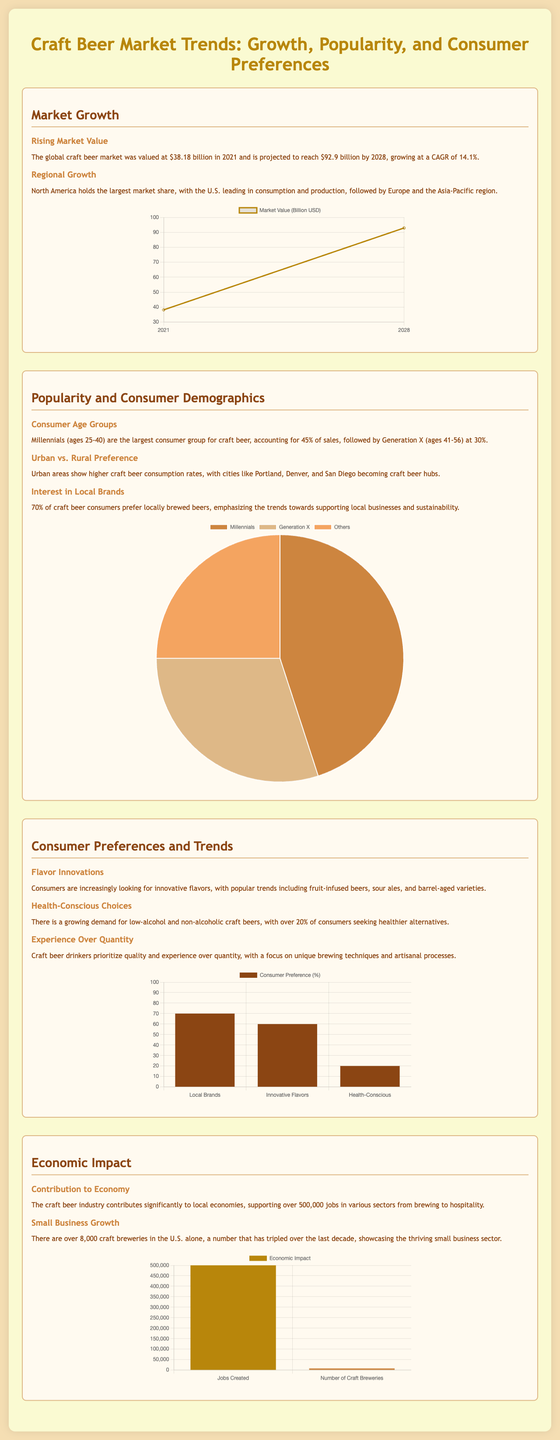What was the global craft beer market value in 2021? The document states that the craft beer market was valued at $38.18 billion in 2021.
Answer: $38.18 billion What is the projected market value by 2028? The document mentions that the market is projected to reach $92.9 billion by 2028.
Answer: $92.9 billion Which age group accounts for the largest consumer group for craft beer? The document states that Millennials (ages 25-40) are the largest consumer group, accounting for 45% of sales.
Answer: Millennials What percentage of craft beer consumers prefer locally brewed beers? According to the document, 70% of craft beer consumers prefer locally brewed beers.
Answer: 70% What is the annual growth rate of the craft beer market? The document indicates that the craft beer market is growing at a CAGR of 14.1%.
Answer: 14.1% How many jobs does the craft beer industry support in various sectors? The document states that the craft beer industry supports over 500,000 jobs.
Answer: 500,000 Which U.S. region holds the largest market share for craft beer? The document specifies that North America holds the largest market share, with the U.S. leading in consumption and production.
Answer: North America What unique consumer trend is emphasized regarding craft beer drinkers? The document highlights that craft beer drinkers prioritize quality and experience over quantity.
Answer: Quality and experience What is the number of craft breweries in the U.S. mentioned in the document? The document states that there are over 8,000 craft breweries in the U.S. alone.
Answer: 8,000 